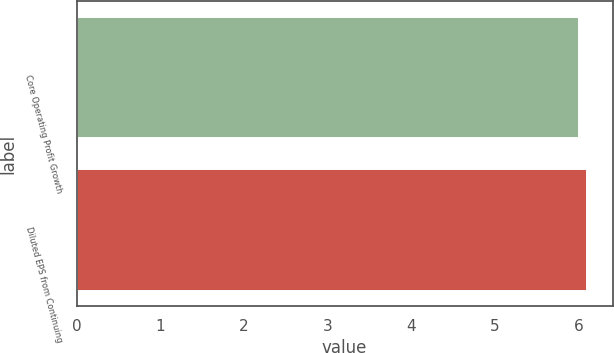Convert chart. <chart><loc_0><loc_0><loc_500><loc_500><bar_chart><fcel>Core Operating Profit Growth<fcel>Diluted EPS from Continuing<nl><fcel>6<fcel>6.1<nl></chart> 